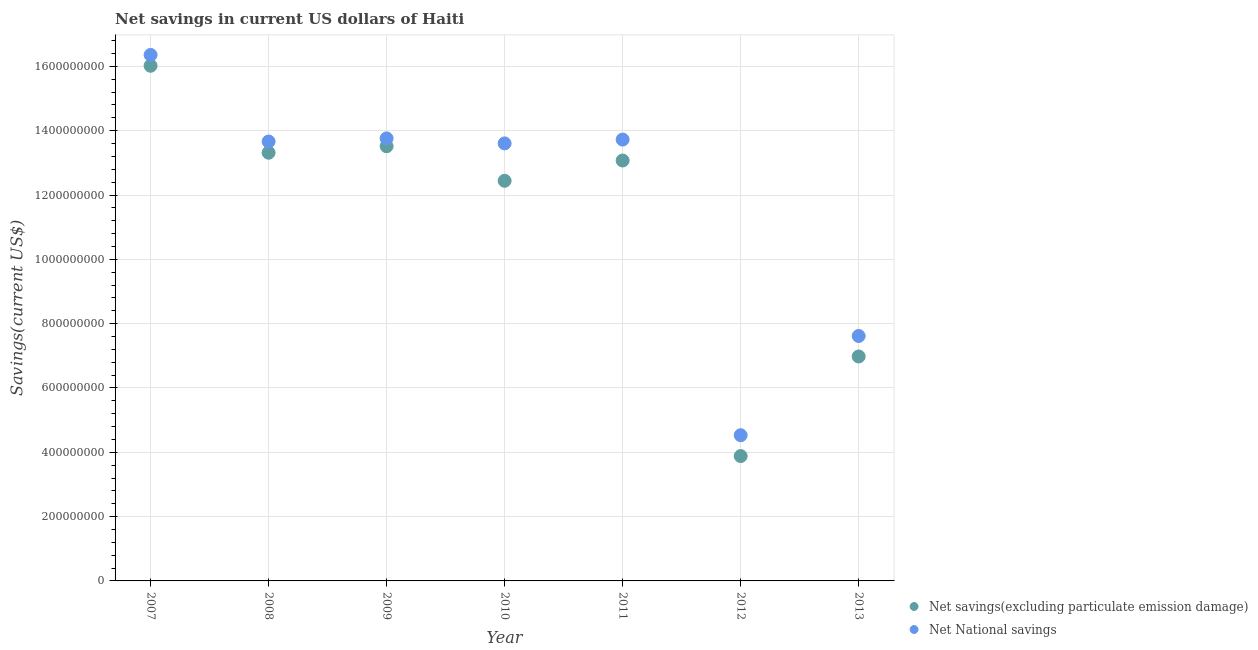How many different coloured dotlines are there?
Your answer should be compact. 2. What is the net national savings in 2008?
Make the answer very short. 1.37e+09. Across all years, what is the maximum net national savings?
Your response must be concise. 1.64e+09. Across all years, what is the minimum net savings(excluding particulate emission damage)?
Keep it short and to the point. 3.88e+08. What is the total net savings(excluding particulate emission damage) in the graph?
Make the answer very short. 7.92e+09. What is the difference between the net national savings in 2009 and that in 2010?
Your answer should be very brief. 1.55e+07. What is the difference between the net national savings in 2010 and the net savings(excluding particulate emission damage) in 2012?
Ensure brevity in your answer.  9.72e+08. What is the average net national savings per year?
Provide a short and direct response. 1.19e+09. In the year 2010, what is the difference between the net savings(excluding particulate emission damage) and net national savings?
Keep it short and to the point. -1.16e+08. In how many years, is the net savings(excluding particulate emission damage) greater than 1480000000 US$?
Your response must be concise. 1. What is the ratio of the net savings(excluding particulate emission damage) in 2007 to that in 2008?
Make the answer very short. 1.2. Is the difference between the net national savings in 2012 and 2013 greater than the difference between the net savings(excluding particulate emission damage) in 2012 and 2013?
Provide a short and direct response. Yes. What is the difference between the highest and the second highest net savings(excluding particulate emission damage)?
Provide a succinct answer. 2.50e+08. What is the difference between the highest and the lowest net savings(excluding particulate emission damage)?
Offer a terse response. 1.21e+09. In how many years, is the net savings(excluding particulate emission damage) greater than the average net savings(excluding particulate emission damage) taken over all years?
Give a very brief answer. 5. Is the sum of the net savings(excluding particulate emission damage) in 2008 and 2011 greater than the maximum net national savings across all years?
Give a very brief answer. Yes. Is the net savings(excluding particulate emission damage) strictly less than the net national savings over the years?
Keep it short and to the point. Yes. How many years are there in the graph?
Keep it short and to the point. 7. Are the values on the major ticks of Y-axis written in scientific E-notation?
Provide a short and direct response. No. How many legend labels are there?
Your answer should be compact. 2. How are the legend labels stacked?
Your answer should be very brief. Vertical. What is the title of the graph?
Your answer should be compact. Net savings in current US dollars of Haiti. What is the label or title of the X-axis?
Your response must be concise. Year. What is the label or title of the Y-axis?
Offer a very short reply. Savings(current US$). What is the Savings(current US$) of Net savings(excluding particulate emission damage) in 2007?
Offer a terse response. 1.60e+09. What is the Savings(current US$) of Net National savings in 2007?
Make the answer very short. 1.64e+09. What is the Savings(current US$) of Net savings(excluding particulate emission damage) in 2008?
Offer a terse response. 1.33e+09. What is the Savings(current US$) of Net National savings in 2008?
Ensure brevity in your answer.  1.37e+09. What is the Savings(current US$) in Net savings(excluding particulate emission damage) in 2009?
Keep it short and to the point. 1.35e+09. What is the Savings(current US$) of Net National savings in 2009?
Make the answer very short. 1.38e+09. What is the Savings(current US$) in Net savings(excluding particulate emission damage) in 2010?
Offer a very short reply. 1.24e+09. What is the Savings(current US$) in Net National savings in 2010?
Offer a very short reply. 1.36e+09. What is the Savings(current US$) of Net savings(excluding particulate emission damage) in 2011?
Your answer should be very brief. 1.31e+09. What is the Savings(current US$) in Net National savings in 2011?
Provide a succinct answer. 1.37e+09. What is the Savings(current US$) of Net savings(excluding particulate emission damage) in 2012?
Make the answer very short. 3.88e+08. What is the Savings(current US$) of Net National savings in 2012?
Ensure brevity in your answer.  4.53e+08. What is the Savings(current US$) of Net savings(excluding particulate emission damage) in 2013?
Provide a succinct answer. 6.98e+08. What is the Savings(current US$) in Net National savings in 2013?
Your response must be concise. 7.62e+08. Across all years, what is the maximum Savings(current US$) in Net savings(excluding particulate emission damage)?
Offer a terse response. 1.60e+09. Across all years, what is the maximum Savings(current US$) in Net National savings?
Provide a short and direct response. 1.64e+09. Across all years, what is the minimum Savings(current US$) of Net savings(excluding particulate emission damage)?
Keep it short and to the point. 3.88e+08. Across all years, what is the minimum Savings(current US$) of Net National savings?
Provide a succinct answer. 4.53e+08. What is the total Savings(current US$) of Net savings(excluding particulate emission damage) in the graph?
Provide a short and direct response. 7.92e+09. What is the total Savings(current US$) of Net National savings in the graph?
Your answer should be compact. 8.33e+09. What is the difference between the Savings(current US$) of Net savings(excluding particulate emission damage) in 2007 and that in 2008?
Offer a terse response. 2.70e+08. What is the difference between the Savings(current US$) of Net National savings in 2007 and that in 2008?
Ensure brevity in your answer.  2.69e+08. What is the difference between the Savings(current US$) of Net savings(excluding particulate emission damage) in 2007 and that in 2009?
Offer a terse response. 2.50e+08. What is the difference between the Savings(current US$) in Net National savings in 2007 and that in 2009?
Your answer should be compact. 2.60e+08. What is the difference between the Savings(current US$) in Net savings(excluding particulate emission damage) in 2007 and that in 2010?
Make the answer very short. 3.58e+08. What is the difference between the Savings(current US$) in Net National savings in 2007 and that in 2010?
Ensure brevity in your answer.  2.75e+08. What is the difference between the Savings(current US$) of Net savings(excluding particulate emission damage) in 2007 and that in 2011?
Offer a very short reply. 2.95e+08. What is the difference between the Savings(current US$) in Net National savings in 2007 and that in 2011?
Your answer should be very brief. 2.63e+08. What is the difference between the Savings(current US$) of Net savings(excluding particulate emission damage) in 2007 and that in 2012?
Your response must be concise. 1.21e+09. What is the difference between the Savings(current US$) in Net National savings in 2007 and that in 2012?
Your response must be concise. 1.18e+09. What is the difference between the Savings(current US$) in Net savings(excluding particulate emission damage) in 2007 and that in 2013?
Offer a very short reply. 9.04e+08. What is the difference between the Savings(current US$) of Net National savings in 2007 and that in 2013?
Your response must be concise. 8.74e+08. What is the difference between the Savings(current US$) of Net savings(excluding particulate emission damage) in 2008 and that in 2009?
Offer a very short reply. -2.01e+07. What is the difference between the Savings(current US$) of Net National savings in 2008 and that in 2009?
Keep it short and to the point. -9.73e+06. What is the difference between the Savings(current US$) of Net savings(excluding particulate emission damage) in 2008 and that in 2010?
Your answer should be very brief. 8.73e+07. What is the difference between the Savings(current US$) of Net National savings in 2008 and that in 2010?
Keep it short and to the point. 5.82e+06. What is the difference between the Savings(current US$) in Net savings(excluding particulate emission damage) in 2008 and that in 2011?
Ensure brevity in your answer.  2.42e+07. What is the difference between the Savings(current US$) of Net National savings in 2008 and that in 2011?
Offer a very short reply. -6.11e+06. What is the difference between the Savings(current US$) of Net savings(excluding particulate emission damage) in 2008 and that in 2012?
Provide a succinct answer. 9.43e+08. What is the difference between the Savings(current US$) in Net National savings in 2008 and that in 2012?
Give a very brief answer. 9.13e+08. What is the difference between the Savings(current US$) in Net savings(excluding particulate emission damage) in 2008 and that in 2013?
Offer a terse response. 6.34e+08. What is the difference between the Savings(current US$) of Net National savings in 2008 and that in 2013?
Your response must be concise. 6.05e+08. What is the difference between the Savings(current US$) of Net savings(excluding particulate emission damage) in 2009 and that in 2010?
Ensure brevity in your answer.  1.07e+08. What is the difference between the Savings(current US$) in Net National savings in 2009 and that in 2010?
Ensure brevity in your answer.  1.55e+07. What is the difference between the Savings(current US$) of Net savings(excluding particulate emission damage) in 2009 and that in 2011?
Keep it short and to the point. 4.43e+07. What is the difference between the Savings(current US$) in Net National savings in 2009 and that in 2011?
Your answer should be compact. 3.62e+06. What is the difference between the Savings(current US$) of Net savings(excluding particulate emission damage) in 2009 and that in 2012?
Keep it short and to the point. 9.63e+08. What is the difference between the Savings(current US$) in Net National savings in 2009 and that in 2012?
Provide a succinct answer. 9.23e+08. What is the difference between the Savings(current US$) in Net savings(excluding particulate emission damage) in 2009 and that in 2013?
Your answer should be very brief. 6.54e+08. What is the difference between the Savings(current US$) of Net National savings in 2009 and that in 2013?
Provide a short and direct response. 6.14e+08. What is the difference between the Savings(current US$) in Net savings(excluding particulate emission damage) in 2010 and that in 2011?
Your answer should be compact. -6.31e+07. What is the difference between the Savings(current US$) in Net National savings in 2010 and that in 2011?
Keep it short and to the point. -1.19e+07. What is the difference between the Savings(current US$) of Net savings(excluding particulate emission damage) in 2010 and that in 2012?
Keep it short and to the point. 8.56e+08. What is the difference between the Savings(current US$) of Net National savings in 2010 and that in 2012?
Ensure brevity in your answer.  9.07e+08. What is the difference between the Savings(current US$) of Net savings(excluding particulate emission damage) in 2010 and that in 2013?
Your answer should be compact. 5.46e+08. What is the difference between the Savings(current US$) of Net National savings in 2010 and that in 2013?
Offer a very short reply. 5.99e+08. What is the difference between the Savings(current US$) in Net savings(excluding particulate emission damage) in 2011 and that in 2012?
Offer a very short reply. 9.19e+08. What is the difference between the Savings(current US$) of Net National savings in 2011 and that in 2012?
Your answer should be compact. 9.19e+08. What is the difference between the Savings(current US$) of Net savings(excluding particulate emission damage) in 2011 and that in 2013?
Ensure brevity in your answer.  6.09e+08. What is the difference between the Savings(current US$) of Net National savings in 2011 and that in 2013?
Provide a succinct answer. 6.11e+08. What is the difference between the Savings(current US$) of Net savings(excluding particulate emission damage) in 2012 and that in 2013?
Your answer should be compact. -3.10e+08. What is the difference between the Savings(current US$) in Net National savings in 2012 and that in 2013?
Ensure brevity in your answer.  -3.09e+08. What is the difference between the Savings(current US$) of Net savings(excluding particulate emission damage) in 2007 and the Savings(current US$) of Net National savings in 2008?
Provide a short and direct response. 2.36e+08. What is the difference between the Savings(current US$) in Net savings(excluding particulate emission damage) in 2007 and the Savings(current US$) in Net National savings in 2009?
Offer a very short reply. 2.26e+08. What is the difference between the Savings(current US$) of Net savings(excluding particulate emission damage) in 2007 and the Savings(current US$) of Net National savings in 2010?
Your answer should be very brief. 2.41e+08. What is the difference between the Savings(current US$) in Net savings(excluding particulate emission damage) in 2007 and the Savings(current US$) in Net National savings in 2011?
Give a very brief answer. 2.29e+08. What is the difference between the Savings(current US$) of Net savings(excluding particulate emission damage) in 2007 and the Savings(current US$) of Net National savings in 2012?
Make the answer very short. 1.15e+09. What is the difference between the Savings(current US$) in Net savings(excluding particulate emission damage) in 2007 and the Savings(current US$) in Net National savings in 2013?
Keep it short and to the point. 8.40e+08. What is the difference between the Savings(current US$) in Net savings(excluding particulate emission damage) in 2008 and the Savings(current US$) in Net National savings in 2009?
Offer a terse response. -4.45e+07. What is the difference between the Savings(current US$) in Net savings(excluding particulate emission damage) in 2008 and the Savings(current US$) in Net National savings in 2010?
Provide a short and direct response. -2.90e+07. What is the difference between the Savings(current US$) of Net savings(excluding particulate emission damage) in 2008 and the Savings(current US$) of Net National savings in 2011?
Provide a succinct answer. -4.09e+07. What is the difference between the Savings(current US$) in Net savings(excluding particulate emission damage) in 2008 and the Savings(current US$) in Net National savings in 2012?
Keep it short and to the point. 8.78e+08. What is the difference between the Savings(current US$) in Net savings(excluding particulate emission damage) in 2008 and the Savings(current US$) in Net National savings in 2013?
Ensure brevity in your answer.  5.70e+08. What is the difference between the Savings(current US$) in Net savings(excluding particulate emission damage) in 2009 and the Savings(current US$) in Net National savings in 2010?
Your answer should be compact. -8.84e+06. What is the difference between the Savings(current US$) in Net savings(excluding particulate emission damage) in 2009 and the Savings(current US$) in Net National savings in 2011?
Provide a short and direct response. -2.08e+07. What is the difference between the Savings(current US$) in Net savings(excluding particulate emission damage) in 2009 and the Savings(current US$) in Net National savings in 2012?
Give a very brief answer. 8.99e+08. What is the difference between the Savings(current US$) in Net savings(excluding particulate emission damage) in 2009 and the Savings(current US$) in Net National savings in 2013?
Offer a terse response. 5.90e+08. What is the difference between the Savings(current US$) of Net savings(excluding particulate emission damage) in 2010 and the Savings(current US$) of Net National savings in 2011?
Your answer should be compact. -1.28e+08. What is the difference between the Savings(current US$) in Net savings(excluding particulate emission damage) in 2010 and the Savings(current US$) in Net National savings in 2012?
Offer a terse response. 7.91e+08. What is the difference between the Savings(current US$) of Net savings(excluding particulate emission damage) in 2010 and the Savings(current US$) of Net National savings in 2013?
Your answer should be very brief. 4.83e+08. What is the difference between the Savings(current US$) of Net savings(excluding particulate emission damage) in 2011 and the Savings(current US$) of Net National savings in 2012?
Give a very brief answer. 8.54e+08. What is the difference between the Savings(current US$) of Net savings(excluding particulate emission damage) in 2011 and the Savings(current US$) of Net National savings in 2013?
Give a very brief answer. 5.46e+08. What is the difference between the Savings(current US$) of Net savings(excluding particulate emission damage) in 2012 and the Savings(current US$) of Net National savings in 2013?
Your answer should be compact. -3.73e+08. What is the average Savings(current US$) of Net savings(excluding particulate emission damage) per year?
Provide a short and direct response. 1.13e+09. What is the average Savings(current US$) in Net National savings per year?
Provide a short and direct response. 1.19e+09. In the year 2007, what is the difference between the Savings(current US$) of Net savings(excluding particulate emission damage) and Savings(current US$) of Net National savings?
Offer a very short reply. -3.37e+07. In the year 2008, what is the difference between the Savings(current US$) of Net savings(excluding particulate emission damage) and Savings(current US$) of Net National savings?
Keep it short and to the point. -3.48e+07. In the year 2009, what is the difference between the Savings(current US$) in Net savings(excluding particulate emission damage) and Savings(current US$) in Net National savings?
Your answer should be very brief. -2.44e+07. In the year 2010, what is the difference between the Savings(current US$) of Net savings(excluding particulate emission damage) and Savings(current US$) of Net National savings?
Your answer should be very brief. -1.16e+08. In the year 2011, what is the difference between the Savings(current US$) in Net savings(excluding particulate emission damage) and Savings(current US$) in Net National savings?
Ensure brevity in your answer.  -6.51e+07. In the year 2012, what is the difference between the Savings(current US$) of Net savings(excluding particulate emission damage) and Savings(current US$) of Net National savings?
Make the answer very short. -6.48e+07. In the year 2013, what is the difference between the Savings(current US$) in Net savings(excluding particulate emission damage) and Savings(current US$) in Net National savings?
Provide a short and direct response. -6.37e+07. What is the ratio of the Savings(current US$) in Net savings(excluding particulate emission damage) in 2007 to that in 2008?
Provide a short and direct response. 1.2. What is the ratio of the Savings(current US$) in Net National savings in 2007 to that in 2008?
Provide a succinct answer. 1.2. What is the ratio of the Savings(current US$) in Net savings(excluding particulate emission damage) in 2007 to that in 2009?
Your answer should be compact. 1.19. What is the ratio of the Savings(current US$) in Net National savings in 2007 to that in 2009?
Your answer should be compact. 1.19. What is the ratio of the Savings(current US$) of Net savings(excluding particulate emission damage) in 2007 to that in 2010?
Keep it short and to the point. 1.29. What is the ratio of the Savings(current US$) of Net National savings in 2007 to that in 2010?
Give a very brief answer. 1.2. What is the ratio of the Savings(current US$) of Net savings(excluding particulate emission damage) in 2007 to that in 2011?
Offer a very short reply. 1.23. What is the ratio of the Savings(current US$) in Net National savings in 2007 to that in 2011?
Your answer should be compact. 1.19. What is the ratio of the Savings(current US$) of Net savings(excluding particulate emission damage) in 2007 to that in 2012?
Ensure brevity in your answer.  4.13. What is the ratio of the Savings(current US$) in Net National savings in 2007 to that in 2012?
Your answer should be compact. 3.61. What is the ratio of the Savings(current US$) of Net savings(excluding particulate emission damage) in 2007 to that in 2013?
Keep it short and to the point. 2.3. What is the ratio of the Savings(current US$) of Net National savings in 2007 to that in 2013?
Make the answer very short. 2.15. What is the ratio of the Savings(current US$) of Net savings(excluding particulate emission damage) in 2008 to that in 2009?
Give a very brief answer. 0.99. What is the ratio of the Savings(current US$) of Net National savings in 2008 to that in 2009?
Offer a terse response. 0.99. What is the ratio of the Savings(current US$) in Net savings(excluding particulate emission damage) in 2008 to that in 2010?
Provide a succinct answer. 1.07. What is the ratio of the Savings(current US$) of Net savings(excluding particulate emission damage) in 2008 to that in 2011?
Keep it short and to the point. 1.02. What is the ratio of the Savings(current US$) of Net National savings in 2008 to that in 2011?
Provide a short and direct response. 1. What is the ratio of the Savings(current US$) of Net savings(excluding particulate emission damage) in 2008 to that in 2012?
Your answer should be very brief. 3.43. What is the ratio of the Savings(current US$) of Net National savings in 2008 to that in 2012?
Your response must be concise. 3.02. What is the ratio of the Savings(current US$) of Net savings(excluding particulate emission damage) in 2008 to that in 2013?
Provide a short and direct response. 1.91. What is the ratio of the Savings(current US$) in Net National savings in 2008 to that in 2013?
Offer a terse response. 1.79. What is the ratio of the Savings(current US$) in Net savings(excluding particulate emission damage) in 2009 to that in 2010?
Keep it short and to the point. 1.09. What is the ratio of the Savings(current US$) in Net National savings in 2009 to that in 2010?
Provide a short and direct response. 1.01. What is the ratio of the Savings(current US$) in Net savings(excluding particulate emission damage) in 2009 to that in 2011?
Make the answer very short. 1.03. What is the ratio of the Savings(current US$) of Net National savings in 2009 to that in 2011?
Offer a terse response. 1. What is the ratio of the Savings(current US$) in Net savings(excluding particulate emission damage) in 2009 to that in 2012?
Offer a terse response. 3.48. What is the ratio of the Savings(current US$) in Net National savings in 2009 to that in 2012?
Offer a very short reply. 3.04. What is the ratio of the Savings(current US$) of Net savings(excluding particulate emission damage) in 2009 to that in 2013?
Your answer should be compact. 1.94. What is the ratio of the Savings(current US$) of Net National savings in 2009 to that in 2013?
Provide a succinct answer. 1.81. What is the ratio of the Savings(current US$) of Net savings(excluding particulate emission damage) in 2010 to that in 2011?
Provide a short and direct response. 0.95. What is the ratio of the Savings(current US$) in Net National savings in 2010 to that in 2011?
Provide a short and direct response. 0.99. What is the ratio of the Savings(current US$) in Net savings(excluding particulate emission damage) in 2010 to that in 2012?
Your answer should be compact. 3.2. What is the ratio of the Savings(current US$) of Net National savings in 2010 to that in 2012?
Ensure brevity in your answer.  3. What is the ratio of the Savings(current US$) of Net savings(excluding particulate emission damage) in 2010 to that in 2013?
Provide a succinct answer. 1.78. What is the ratio of the Savings(current US$) in Net National savings in 2010 to that in 2013?
Your answer should be very brief. 1.79. What is the ratio of the Savings(current US$) in Net savings(excluding particulate emission damage) in 2011 to that in 2012?
Ensure brevity in your answer.  3.37. What is the ratio of the Savings(current US$) in Net National savings in 2011 to that in 2012?
Provide a short and direct response. 3.03. What is the ratio of the Savings(current US$) of Net savings(excluding particulate emission damage) in 2011 to that in 2013?
Provide a succinct answer. 1.87. What is the ratio of the Savings(current US$) in Net National savings in 2011 to that in 2013?
Provide a short and direct response. 1.8. What is the ratio of the Savings(current US$) of Net savings(excluding particulate emission damage) in 2012 to that in 2013?
Your answer should be very brief. 0.56. What is the ratio of the Savings(current US$) in Net National savings in 2012 to that in 2013?
Your answer should be very brief. 0.59. What is the difference between the highest and the second highest Savings(current US$) of Net savings(excluding particulate emission damage)?
Offer a terse response. 2.50e+08. What is the difference between the highest and the second highest Savings(current US$) of Net National savings?
Make the answer very short. 2.60e+08. What is the difference between the highest and the lowest Savings(current US$) in Net savings(excluding particulate emission damage)?
Keep it short and to the point. 1.21e+09. What is the difference between the highest and the lowest Savings(current US$) of Net National savings?
Your response must be concise. 1.18e+09. 